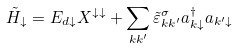Convert formula to latex. <formula><loc_0><loc_0><loc_500><loc_500>\tilde { H } _ { \downarrow } = E _ { d \downarrow } X ^ { \downarrow \downarrow } + \sum _ { k k ^ { \prime } } \tilde { \varepsilon } ^ { \sigma } _ { k k ^ { \prime } } a ^ { \dag } _ { k \downarrow } a _ { k ^ { \prime } \downarrow }</formula> 